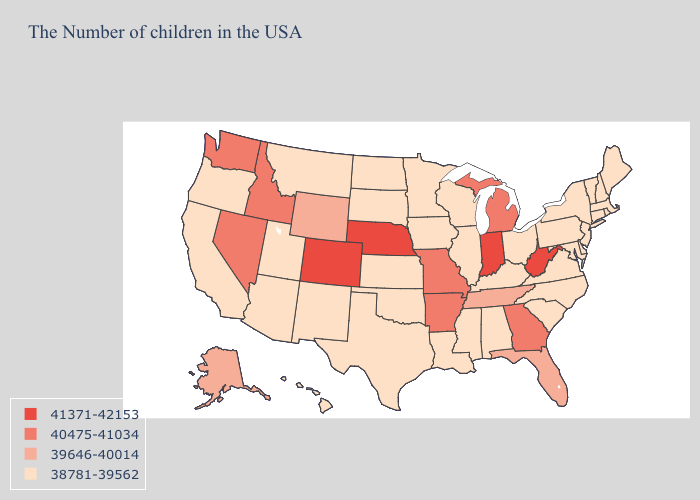Does the first symbol in the legend represent the smallest category?
Be succinct. No. Among the states that border Indiana , does Michigan have the lowest value?
Answer briefly. No. Does Connecticut have a higher value than Montana?
Write a very short answer. No. What is the lowest value in the South?
Concise answer only. 38781-39562. What is the value of Mississippi?
Concise answer only. 38781-39562. Which states have the lowest value in the USA?
Short answer required. Maine, Massachusetts, Rhode Island, New Hampshire, Vermont, Connecticut, New York, New Jersey, Delaware, Maryland, Pennsylvania, Virginia, North Carolina, South Carolina, Ohio, Kentucky, Alabama, Wisconsin, Illinois, Mississippi, Louisiana, Minnesota, Iowa, Kansas, Oklahoma, Texas, South Dakota, North Dakota, New Mexico, Utah, Montana, Arizona, California, Oregon, Hawaii. Among the states that border Arkansas , does Texas have the highest value?
Answer briefly. No. What is the lowest value in the USA?
Be succinct. 38781-39562. How many symbols are there in the legend?
Short answer required. 4. What is the value of Connecticut?
Answer briefly. 38781-39562. What is the value of Kansas?
Be succinct. 38781-39562. Name the states that have a value in the range 39646-40014?
Short answer required. Florida, Tennessee, Wyoming, Alaska. What is the lowest value in the USA?
Concise answer only. 38781-39562. What is the value of Ohio?
Keep it brief. 38781-39562. Name the states that have a value in the range 38781-39562?
Answer briefly. Maine, Massachusetts, Rhode Island, New Hampshire, Vermont, Connecticut, New York, New Jersey, Delaware, Maryland, Pennsylvania, Virginia, North Carolina, South Carolina, Ohio, Kentucky, Alabama, Wisconsin, Illinois, Mississippi, Louisiana, Minnesota, Iowa, Kansas, Oklahoma, Texas, South Dakota, North Dakota, New Mexico, Utah, Montana, Arizona, California, Oregon, Hawaii. 